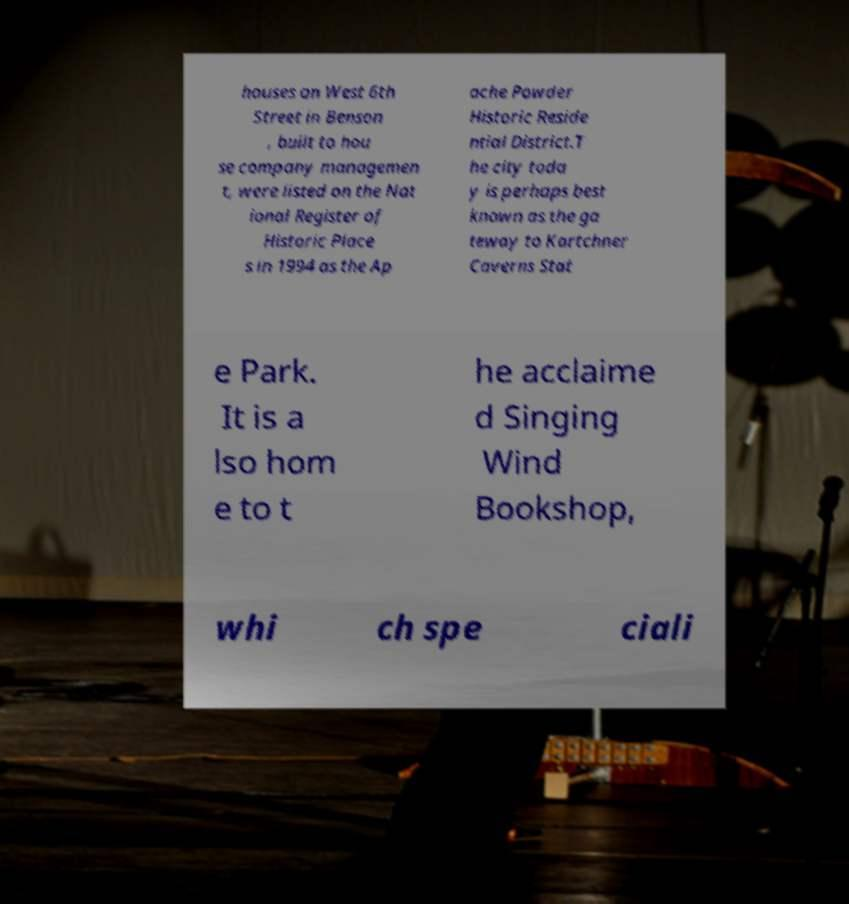Can you read and provide the text displayed in the image?This photo seems to have some interesting text. Can you extract and type it out for me? houses on West 6th Street in Benson , built to hou se company managemen t, were listed on the Nat ional Register of Historic Place s in 1994 as the Ap ache Powder Historic Reside ntial District.T he city toda y is perhaps best known as the ga teway to Kartchner Caverns Stat e Park. It is a lso hom e to t he acclaime d Singing Wind Bookshop, whi ch spe ciali 